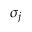Convert formula to latex. <formula><loc_0><loc_0><loc_500><loc_500>\sigma _ { j }</formula> 